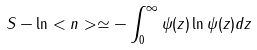<formula> <loc_0><loc_0><loc_500><loc_500>S - \ln < n > \simeq - \int _ { 0 } ^ { \infty } \psi ( z ) \ln \psi ( z ) d z</formula> 